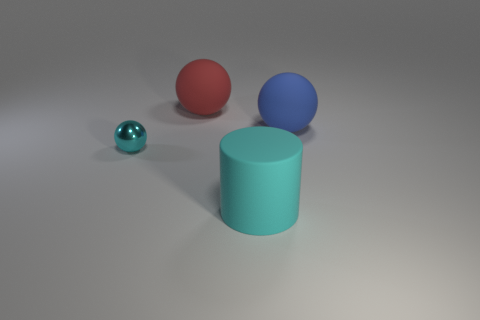How many cylinders are the same color as the small object?
Offer a terse response. 1. There is a cyan metallic sphere in front of the big blue rubber object; is there a large blue rubber object on the right side of it?
Keep it short and to the point. Yes. Is the color of the ball to the left of the large red thing the same as the matte thing in front of the small cyan shiny sphere?
Provide a succinct answer. Yes. What is the color of the rubber ball that is the same size as the blue thing?
Keep it short and to the point. Red. Is the number of blue rubber objects that are right of the cyan metallic object the same as the number of big cyan objects that are on the right side of the blue rubber ball?
Keep it short and to the point. No. What is the ball that is on the right side of the rubber thing in front of the tiny ball made of?
Offer a terse response. Rubber. What number of things are either big spheres or big green cylinders?
Make the answer very short. 2. What size is the object that is the same color as the matte cylinder?
Ensure brevity in your answer.  Small. Is the number of blue rubber balls less than the number of blue cylinders?
Keep it short and to the point. No. The cylinder that is the same material as the large blue ball is what size?
Make the answer very short. Large. 